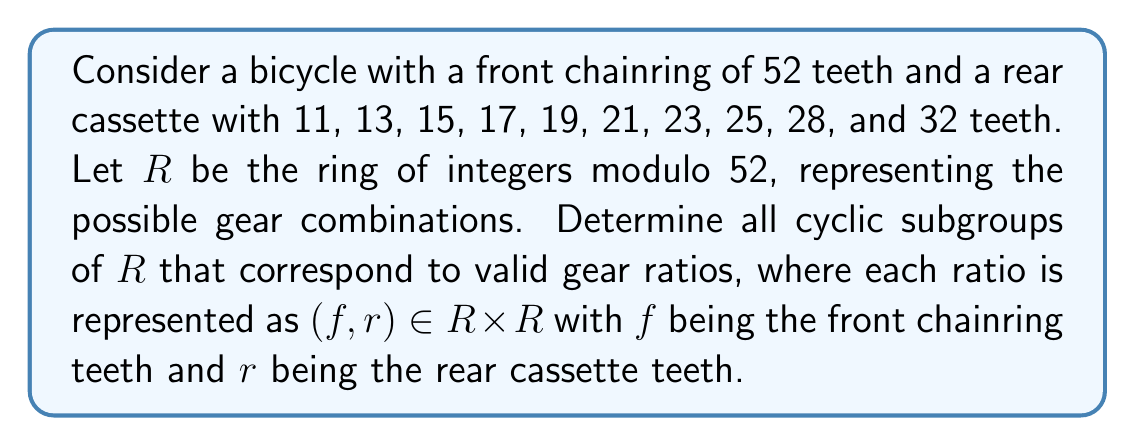Solve this math problem. To solve this problem, we need to follow these steps:

1) First, we need to understand that $R = \mathbb{Z}_{52}$, the ring of integers modulo 52.

2) The valid rear cassette teeth numbers in $R$ are: 11, 13, 15, 17, 19, 21, 23, 25, 28, 32. We only need to consider these elements of $R$.

3) For each rear cassette tooth number $r$, we need to find the cyclic subgroup generated by $(1, r)$ in $R \times R$.

4) The order of each element $(1, r)$ in $R \times R$ is the least common multiple of the orders of 1 and $r$ in $R$.

5) In $\mathbb{Z}_{52}$, the order of 1 is always 52.

6) For each $r$, we need to find its order in $\mathbb{Z}_{52}$. This is given by $\frac{52}{\gcd(52, r)}$.

Let's calculate this for each $r$:

- For 11: $\gcd(52, 11) = 1$, so order is 52
- For 13: $\gcd(52, 13) = 13$, so order is 4
- For 15: $\gcd(52, 15) = 1$, so order is 52
- For 17: $\gcd(52, 17) = 1$, so order is 52
- For 19: $\gcd(52, 19) = 1$, so order is 52
- For 21: $\gcd(52, 21) = 1$, so order is 52
- For 23: $\gcd(52, 23) = 1$, so order is 52
- For 25: $\gcd(52, 25) = 1$, so order is 52
- For 28: $\gcd(52, 28) = 4$, so order is 13
- For 32: $\gcd(52, 32) = 4$, so order is 13

7) The cyclic subgroup generated by each $(1, r)$ will have the same order as calculated above.

Therefore, we have:
- Cyclic subgroups of order 52 for $r = 11, 15, 17, 19, 21, 23, 25$
- Cyclic subgroup of order 4 for $r = 13$
- Cyclic subgroups of order 13 for $r = 28, 32$
Answer: The cyclic subgroups of $R$ corresponding to valid gear ratios are:
- 7 cyclic subgroups of order 52, generated by $(1, r)$ for $r = 11, 15, 17, 19, 21, 23, 25$
- 1 cyclic subgroup of order 4, generated by $(1, 13)$
- 2 cyclic subgroups of order 13, generated by $(1, 28)$ and $(1, 32)$ 